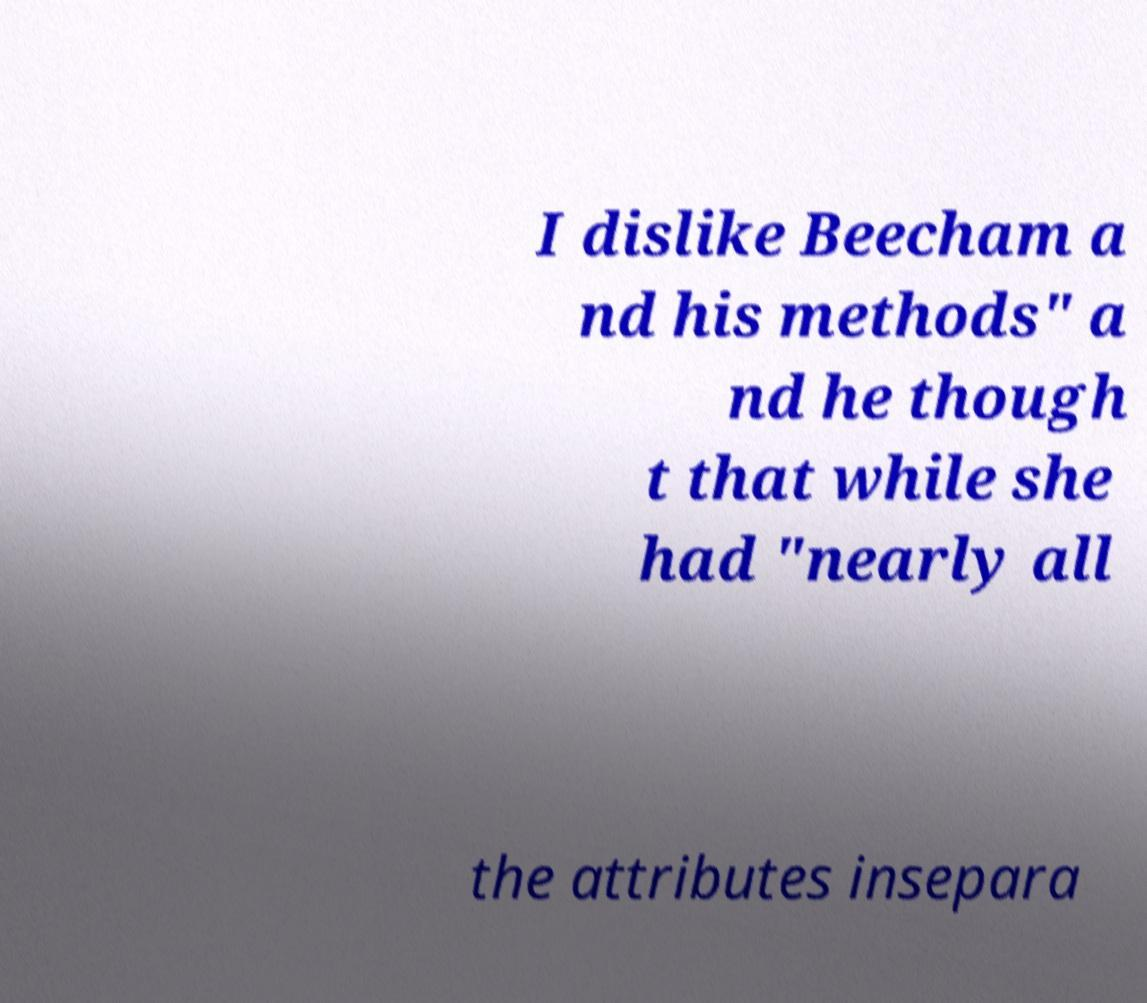I need the written content from this picture converted into text. Can you do that? I dislike Beecham a nd his methods" a nd he though t that while she had "nearly all the attributes insepara 